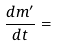Convert formula to latex. <formula><loc_0><loc_0><loc_500><loc_500>\frac { d m ^ { \prime } } { d t } =</formula> 